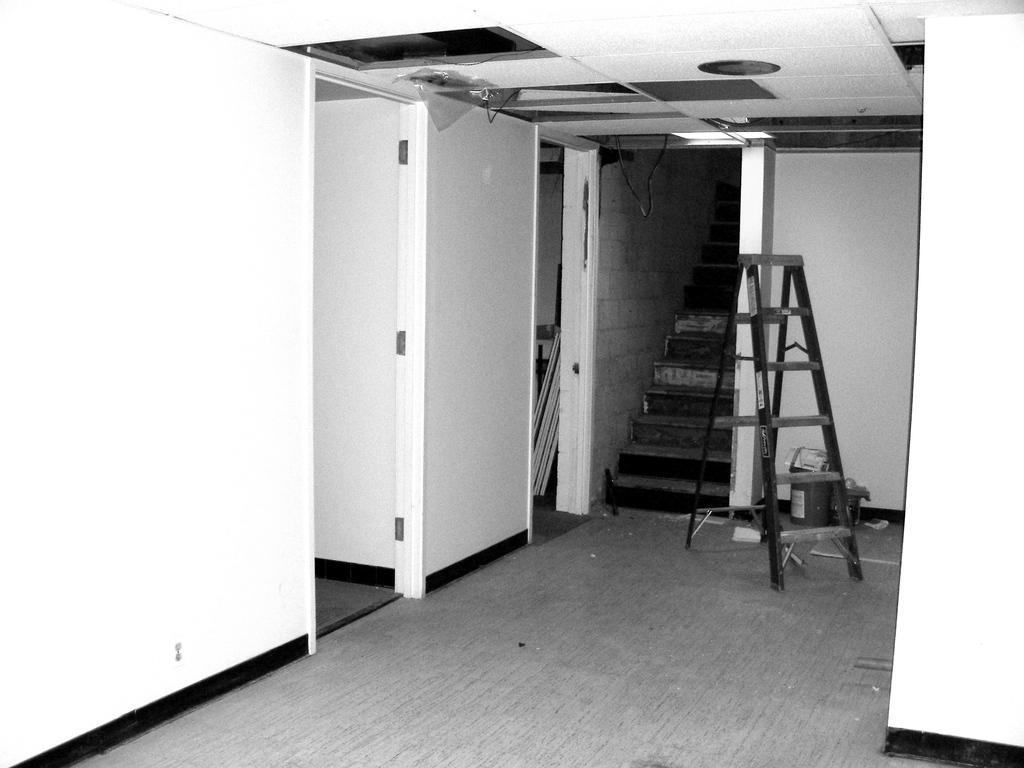Can you describe this image briefly? In this picture I can see the inside view of a building and on the floor, I can see a ladder and other few things. In the background I can see the steps. 